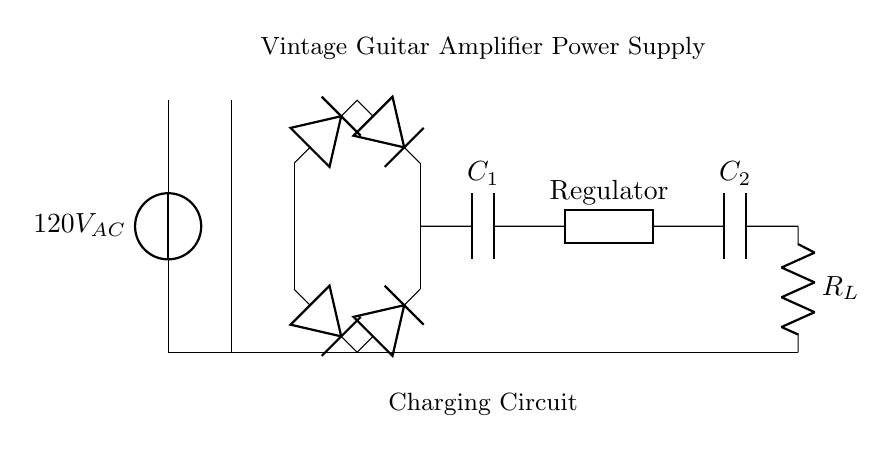What is the input voltage of the circuit? The input voltage is labeled as 120V AC, which is the voltage supplied to the circuit from the power source.
Answer: 120V AC What type of component is C1? C1 is labeled as a capacitor, which indicates that it stores charge and helps to smooth out the output voltage in the circuit.
Answer: Capacitor How many diodes are used in the rectifier bridge? There are four diodes visible in the circuit diagram, arranged in a bridge configuration to rectify the AC voltage.
Answer: Four What is the purpose of the smoothing capacitor, C1? The smoothing capacitor C1 reduces voltage fluctuations and ripple in the output by charging and discharging, thereby providing a more constant voltage to the regulator.
Answer: Smooth output voltage What is the function of the voltage regulator in this circuit? The voltage regulator ensures that the output voltage remains stable despite variations in the input voltage or load conditions by automatically adjusting its resistance to maintain a constant output.
Answer: Regulates voltage Where is the load resistor located? The load resistor is located at the end of the circuit, connected directly to the output capacitor, indicating where the power is delivered in the circuit.
Answer: At the output What type of circuit is represented here? The circuit is a charging circuit specifically designed for powering a vintage guitar amplifier, indicated by the components and structure that support AC to DC conversion.
Answer: Charging circuit 